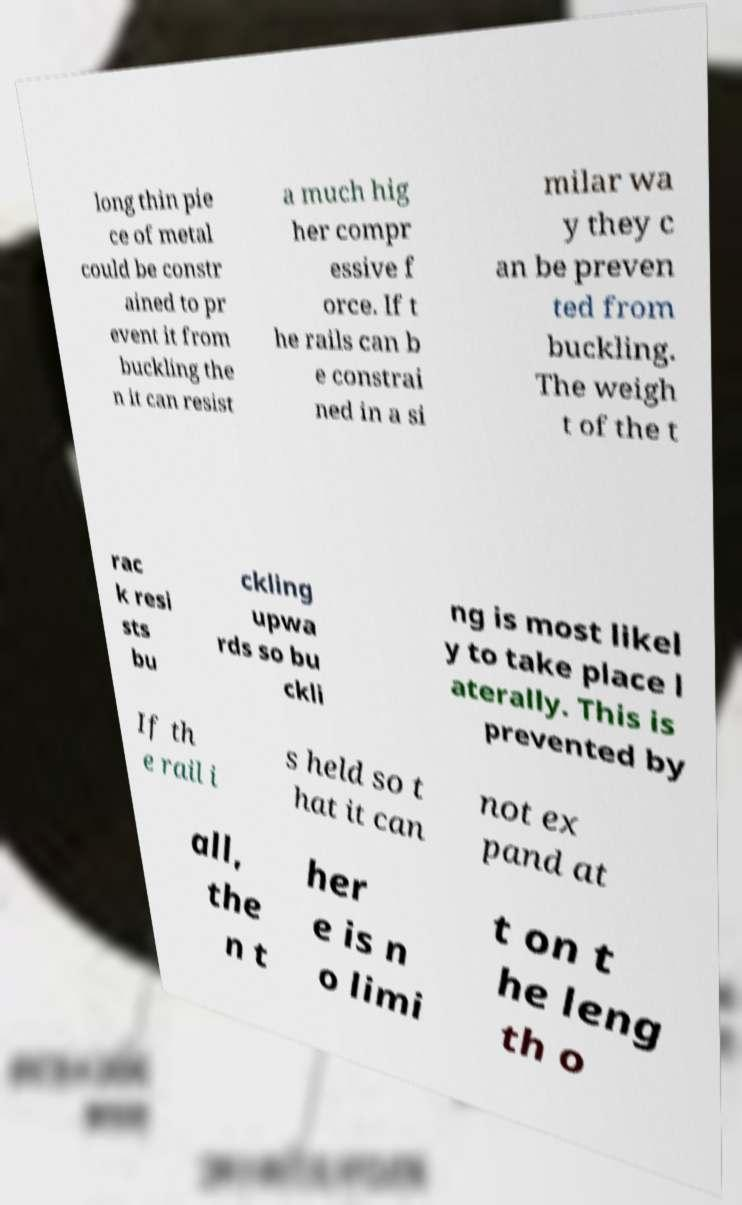Can you read and provide the text displayed in the image?This photo seems to have some interesting text. Can you extract and type it out for me? long thin pie ce of metal could be constr ained to pr event it from buckling the n it can resist a much hig her compr essive f orce. If t he rails can b e constrai ned in a si milar wa y they c an be preven ted from buckling. The weigh t of the t rac k resi sts bu ckling upwa rds so bu ckli ng is most likel y to take place l aterally. This is prevented by If th e rail i s held so t hat it can not ex pand at all, the n t her e is n o limi t on t he leng th o 